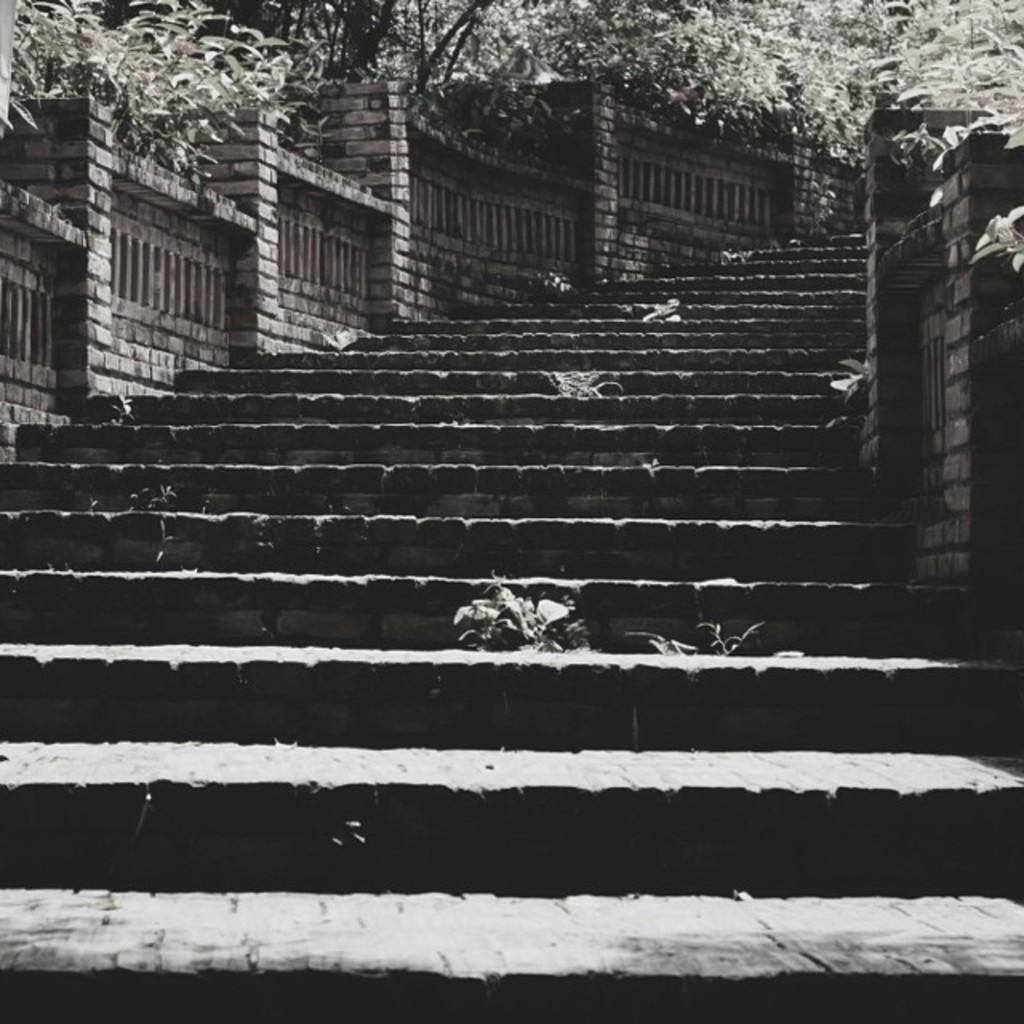Could you give a brief overview of what you see in this image? In this picture I can see the steps and the walls in front. In the background I can see the trees and few plants. 